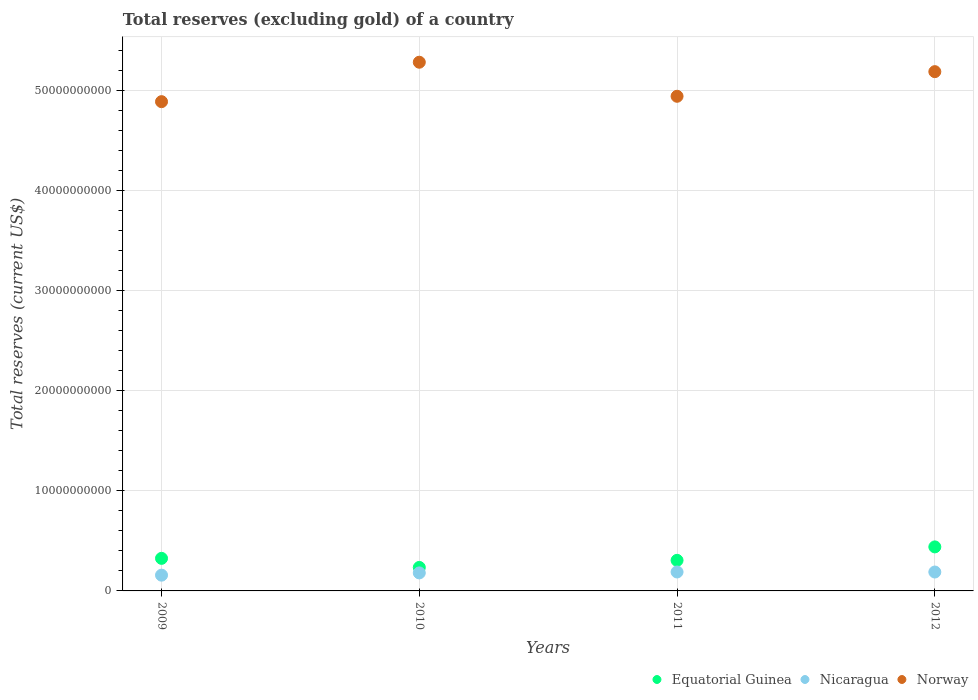Is the number of dotlines equal to the number of legend labels?
Your answer should be compact. Yes. What is the total reserves (excluding gold) in Nicaragua in 2010?
Provide a succinct answer. 1.80e+09. Across all years, what is the maximum total reserves (excluding gold) in Nicaragua?
Provide a succinct answer. 1.89e+09. Across all years, what is the minimum total reserves (excluding gold) in Equatorial Guinea?
Give a very brief answer. 2.35e+09. In which year was the total reserves (excluding gold) in Norway maximum?
Give a very brief answer. 2010. What is the total total reserves (excluding gold) in Nicaragua in the graph?
Provide a short and direct response. 7.15e+09. What is the difference between the total reserves (excluding gold) in Equatorial Guinea in 2009 and that in 2011?
Provide a short and direct response. 1.98e+08. What is the difference between the total reserves (excluding gold) in Nicaragua in 2011 and the total reserves (excluding gold) in Equatorial Guinea in 2012?
Give a very brief answer. -2.50e+09. What is the average total reserves (excluding gold) in Equatorial Guinea per year?
Provide a succinct answer. 3.26e+09. In the year 2010, what is the difference between the total reserves (excluding gold) in Norway and total reserves (excluding gold) in Equatorial Guinea?
Provide a succinct answer. 5.05e+1. What is the ratio of the total reserves (excluding gold) in Equatorial Guinea in 2009 to that in 2012?
Ensure brevity in your answer.  0.74. Is the difference between the total reserves (excluding gold) in Norway in 2009 and 2012 greater than the difference between the total reserves (excluding gold) in Equatorial Guinea in 2009 and 2012?
Ensure brevity in your answer.  No. What is the difference between the highest and the second highest total reserves (excluding gold) in Equatorial Guinea?
Make the answer very short. 1.15e+09. What is the difference between the highest and the lowest total reserves (excluding gold) in Nicaragua?
Keep it short and to the point. 3.19e+08. In how many years, is the total reserves (excluding gold) in Norway greater than the average total reserves (excluding gold) in Norway taken over all years?
Offer a terse response. 2. Is it the case that in every year, the sum of the total reserves (excluding gold) in Norway and total reserves (excluding gold) in Nicaragua  is greater than the total reserves (excluding gold) in Equatorial Guinea?
Make the answer very short. Yes. Does the total reserves (excluding gold) in Nicaragua monotonically increase over the years?
Your answer should be very brief. No. How many years are there in the graph?
Offer a terse response. 4. What is the difference between two consecutive major ticks on the Y-axis?
Provide a short and direct response. 1.00e+1. Are the values on the major ticks of Y-axis written in scientific E-notation?
Give a very brief answer. No. Does the graph contain any zero values?
Your response must be concise. No. How many legend labels are there?
Your response must be concise. 3. How are the legend labels stacked?
Offer a terse response. Horizontal. What is the title of the graph?
Offer a very short reply. Total reserves (excluding gold) of a country. Does "Argentina" appear as one of the legend labels in the graph?
Your answer should be very brief. No. What is the label or title of the Y-axis?
Give a very brief answer. Total reserves (current US$). What is the Total reserves (current US$) of Equatorial Guinea in 2009?
Offer a very short reply. 3.25e+09. What is the Total reserves (current US$) of Nicaragua in 2009?
Make the answer very short. 1.57e+09. What is the Total reserves (current US$) in Norway in 2009?
Make the answer very short. 4.89e+1. What is the Total reserves (current US$) of Equatorial Guinea in 2010?
Give a very brief answer. 2.35e+09. What is the Total reserves (current US$) in Nicaragua in 2010?
Your answer should be compact. 1.80e+09. What is the Total reserves (current US$) in Norway in 2010?
Provide a short and direct response. 5.28e+1. What is the Total reserves (current US$) in Equatorial Guinea in 2011?
Give a very brief answer. 3.05e+09. What is the Total reserves (current US$) of Nicaragua in 2011?
Make the answer very short. 1.89e+09. What is the Total reserves (current US$) in Norway in 2011?
Your answer should be compact. 4.94e+1. What is the Total reserves (current US$) of Equatorial Guinea in 2012?
Keep it short and to the point. 4.40e+09. What is the Total reserves (current US$) of Nicaragua in 2012?
Provide a short and direct response. 1.89e+09. What is the Total reserves (current US$) of Norway in 2012?
Provide a succinct answer. 5.19e+1. Across all years, what is the maximum Total reserves (current US$) in Equatorial Guinea?
Give a very brief answer. 4.40e+09. Across all years, what is the maximum Total reserves (current US$) of Nicaragua?
Provide a succinct answer. 1.89e+09. Across all years, what is the maximum Total reserves (current US$) in Norway?
Provide a short and direct response. 5.28e+1. Across all years, what is the minimum Total reserves (current US$) in Equatorial Guinea?
Your response must be concise. 2.35e+09. Across all years, what is the minimum Total reserves (current US$) in Nicaragua?
Offer a very short reply. 1.57e+09. Across all years, what is the minimum Total reserves (current US$) in Norway?
Offer a very short reply. 4.89e+1. What is the total Total reserves (current US$) of Equatorial Guinea in the graph?
Make the answer very short. 1.30e+1. What is the total Total reserves (current US$) of Nicaragua in the graph?
Ensure brevity in your answer.  7.15e+09. What is the total Total reserves (current US$) in Norway in the graph?
Keep it short and to the point. 2.03e+11. What is the difference between the Total reserves (current US$) of Equatorial Guinea in 2009 and that in 2010?
Your answer should be compact. 9.06e+08. What is the difference between the Total reserves (current US$) of Nicaragua in 2009 and that in 2010?
Offer a terse response. -2.26e+08. What is the difference between the Total reserves (current US$) in Norway in 2009 and that in 2010?
Your answer should be compact. -3.94e+09. What is the difference between the Total reserves (current US$) in Equatorial Guinea in 2009 and that in 2011?
Your answer should be compact. 1.98e+08. What is the difference between the Total reserves (current US$) of Nicaragua in 2009 and that in 2011?
Your response must be concise. -3.19e+08. What is the difference between the Total reserves (current US$) in Norway in 2009 and that in 2011?
Keep it short and to the point. -5.38e+08. What is the difference between the Total reserves (current US$) in Equatorial Guinea in 2009 and that in 2012?
Provide a succinct answer. -1.15e+09. What is the difference between the Total reserves (current US$) of Nicaragua in 2009 and that in 2012?
Offer a very short reply. -3.14e+08. What is the difference between the Total reserves (current US$) of Norway in 2009 and that in 2012?
Provide a succinct answer. -3.00e+09. What is the difference between the Total reserves (current US$) in Equatorial Guinea in 2010 and that in 2011?
Give a very brief answer. -7.07e+08. What is the difference between the Total reserves (current US$) in Nicaragua in 2010 and that in 2011?
Provide a short and direct response. -9.33e+07. What is the difference between the Total reserves (current US$) of Norway in 2010 and that in 2011?
Provide a succinct answer. 3.40e+09. What is the difference between the Total reserves (current US$) in Equatorial Guinea in 2010 and that in 2012?
Offer a terse response. -2.05e+09. What is the difference between the Total reserves (current US$) of Nicaragua in 2010 and that in 2012?
Offer a very short reply. -8.82e+07. What is the difference between the Total reserves (current US$) in Norway in 2010 and that in 2012?
Ensure brevity in your answer.  9.42e+08. What is the difference between the Total reserves (current US$) of Equatorial Guinea in 2011 and that in 2012?
Your response must be concise. -1.34e+09. What is the difference between the Total reserves (current US$) of Nicaragua in 2011 and that in 2012?
Provide a short and direct response. 5.03e+06. What is the difference between the Total reserves (current US$) in Norway in 2011 and that in 2012?
Offer a terse response. -2.46e+09. What is the difference between the Total reserves (current US$) in Equatorial Guinea in 2009 and the Total reserves (current US$) in Nicaragua in 2010?
Offer a very short reply. 1.45e+09. What is the difference between the Total reserves (current US$) of Equatorial Guinea in 2009 and the Total reserves (current US$) of Norway in 2010?
Provide a short and direct response. -4.95e+1. What is the difference between the Total reserves (current US$) of Nicaragua in 2009 and the Total reserves (current US$) of Norway in 2010?
Offer a very short reply. -5.12e+1. What is the difference between the Total reserves (current US$) of Equatorial Guinea in 2009 and the Total reserves (current US$) of Nicaragua in 2011?
Offer a very short reply. 1.36e+09. What is the difference between the Total reserves (current US$) of Equatorial Guinea in 2009 and the Total reserves (current US$) of Norway in 2011?
Make the answer very short. -4.61e+1. What is the difference between the Total reserves (current US$) in Nicaragua in 2009 and the Total reserves (current US$) in Norway in 2011?
Keep it short and to the point. -4.78e+1. What is the difference between the Total reserves (current US$) in Equatorial Guinea in 2009 and the Total reserves (current US$) in Nicaragua in 2012?
Make the answer very short. 1.36e+09. What is the difference between the Total reserves (current US$) in Equatorial Guinea in 2009 and the Total reserves (current US$) in Norway in 2012?
Give a very brief answer. -4.86e+1. What is the difference between the Total reserves (current US$) of Nicaragua in 2009 and the Total reserves (current US$) of Norway in 2012?
Offer a very short reply. -5.03e+1. What is the difference between the Total reserves (current US$) of Equatorial Guinea in 2010 and the Total reserves (current US$) of Nicaragua in 2011?
Provide a short and direct response. 4.54e+08. What is the difference between the Total reserves (current US$) in Equatorial Guinea in 2010 and the Total reserves (current US$) in Norway in 2011?
Keep it short and to the point. -4.71e+1. What is the difference between the Total reserves (current US$) in Nicaragua in 2010 and the Total reserves (current US$) in Norway in 2011?
Your response must be concise. -4.76e+1. What is the difference between the Total reserves (current US$) of Equatorial Guinea in 2010 and the Total reserves (current US$) of Nicaragua in 2012?
Provide a short and direct response. 4.59e+08. What is the difference between the Total reserves (current US$) of Equatorial Guinea in 2010 and the Total reserves (current US$) of Norway in 2012?
Provide a succinct answer. -4.95e+1. What is the difference between the Total reserves (current US$) in Nicaragua in 2010 and the Total reserves (current US$) in Norway in 2012?
Provide a succinct answer. -5.01e+1. What is the difference between the Total reserves (current US$) in Equatorial Guinea in 2011 and the Total reserves (current US$) in Nicaragua in 2012?
Offer a very short reply. 1.17e+09. What is the difference between the Total reserves (current US$) of Equatorial Guinea in 2011 and the Total reserves (current US$) of Norway in 2012?
Give a very brief answer. -4.88e+1. What is the difference between the Total reserves (current US$) of Nicaragua in 2011 and the Total reserves (current US$) of Norway in 2012?
Offer a very short reply. -5.00e+1. What is the average Total reserves (current US$) of Equatorial Guinea per year?
Give a very brief answer. 3.26e+09. What is the average Total reserves (current US$) of Nicaragua per year?
Make the answer very short. 1.79e+09. What is the average Total reserves (current US$) of Norway per year?
Ensure brevity in your answer.  5.07e+1. In the year 2009, what is the difference between the Total reserves (current US$) in Equatorial Guinea and Total reserves (current US$) in Nicaragua?
Offer a very short reply. 1.68e+09. In the year 2009, what is the difference between the Total reserves (current US$) of Equatorial Guinea and Total reserves (current US$) of Norway?
Offer a very short reply. -4.56e+1. In the year 2009, what is the difference between the Total reserves (current US$) in Nicaragua and Total reserves (current US$) in Norway?
Offer a terse response. -4.73e+1. In the year 2010, what is the difference between the Total reserves (current US$) of Equatorial Guinea and Total reserves (current US$) of Nicaragua?
Your answer should be compact. 5.47e+08. In the year 2010, what is the difference between the Total reserves (current US$) of Equatorial Guinea and Total reserves (current US$) of Norway?
Provide a succinct answer. -5.05e+1. In the year 2010, what is the difference between the Total reserves (current US$) in Nicaragua and Total reserves (current US$) in Norway?
Offer a very short reply. -5.10e+1. In the year 2011, what is the difference between the Total reserves (current US$) in Equatorial Guinea and Total reserves (current US$) in Nicaragua?
Ensure brevity in your answer.  1.16e+09. In the year 2011, what is the difference between the Total reserves (current US$) in Equatorial Guinea and Total reserves (current US$) in Norway?
Offer a terse response. -4.63e+1. In the year 2011, what is the difference between the Total reserves (current US$) in Nicaragua and Total reserves (current US$) in Norway?
Provide a short and direct response. -4.75e+1. In the year 2012, what is the difference between the Total reserves (current US$) of Equatorial Guinea and Total reserves (current US$) of Nicaragua?
Provide a short and direct response. 2.51e+09. In the year 2012, what is the difference between the Total reserves (current US$) in Equatorial Guinea and Total reserves (current US$) in Norway?
Provide a succinct answer. -4.75e+1. In the year 2012, what is the difference between the Total reserves (current US$) in Nicaragua and Total reserves (current US$) in Norway?
Give a very brief answer. -5.00e+1. What is the ratio of the Total reserves (current US$) of Equatorial Guinea in 2009 to that in 2010?
Offer a terse response. 1.39. What is the ratio of the Total reserves (current US$) of Nicaragua in 2009 to that in 2010?
Provide a succinct answer. 0.87. What is the ratio of the Total reserves (current US$) in Norway in 2009 to that in 2010?
Give a very brief answer. 0.93. What is the ratio of the Total reserves (current US$) of Equatorial Guinea in 2009 to that in 2011?
Offer a terse response. 1.06. What is the ratio of the Total reserves (current US$) in Nicaragua in 2009 to that in 2011?
Give a very brief answer. 0.83. What is the ratio of the Total reserves (current US$) of Norway in 2009 to that in 2011?
Your response must be concise. 0.99. What is the ratio of the Total reserves (current US$) of Equatorial Guinea in 2009 to that in 2012?
Offer a terse response. 0.74. What is the ratio of the Total reserves (current US$) in Nicaragua in 2009 to that in 2012?
Keep it short and to the point. 0.83. What is the ratio of the Total reserves (current US$) in Norway in 2009 to that in 2012?
Provide a succinct answer. 0.94. What is the ratio of the Total reserves (current US$) of Equatorial Guinea in 2010 to that in 2011?
Keep it short and to the point. 0.77. What is the ratio of the Total reserves (current US$) of Nicaragua in 2010 to that in 2011?
Keep it short and to the point. 0.95. What is the ratio of the Total reserves (current US$) of Norway in 2010 to that in 2011?
Ensure brevity in your answer.  1.07. What is the ratio of the Total reserves (current US$) of Equatorial Guinea in 2010 to that in 2012?
Give a very brief answer. 0.53. What is the ratio of the Total reserves (current US$) of Nicaragua in 2010 to that in 2012?
Make the answer very short. 0.95. What is the ratio of the Total reserves (current US$) of Norway in 2010 to that in 2012?
Ensure brevity in your answer.  1.02. What is the ratio of the Total reserves (current US$) in Equatorial Guinea in 2011 to that in 2012?
Offer a very short reply. 0.69. What is the ratio of the Total reserves (current US$) of Norway in 2011 to that in 2012?
Make the answer very short. 0.95. What is the difference between the highest and the second highest Total reserves (current US$) of Equatorial Guinea?
Offer a very short reply. 1.15e+09. What is the difference between the highest and the second highest Total reserves (current US$) of Nicaragua?
Provide a succinct answer. 5.03e+06. What is the difference between the highest and the second highest Total reserves (current US$) in Norway?
Keep it short and to the point. 9.42e+08. What is the difference between the highest and the lowest Total reserves (current US$) in Equatorial Guinea?
Offer a terse response. 2.05e+09. What is the difference between the highest and the lowest Total reserves (current US$) in Nicaragua?
Provide a succinct answer. 3.19e+08. What is the difference between the highest and the lowest Total reserves (current US$) of Norway?
Ensure brevity in your answer.  3.94e+09. 